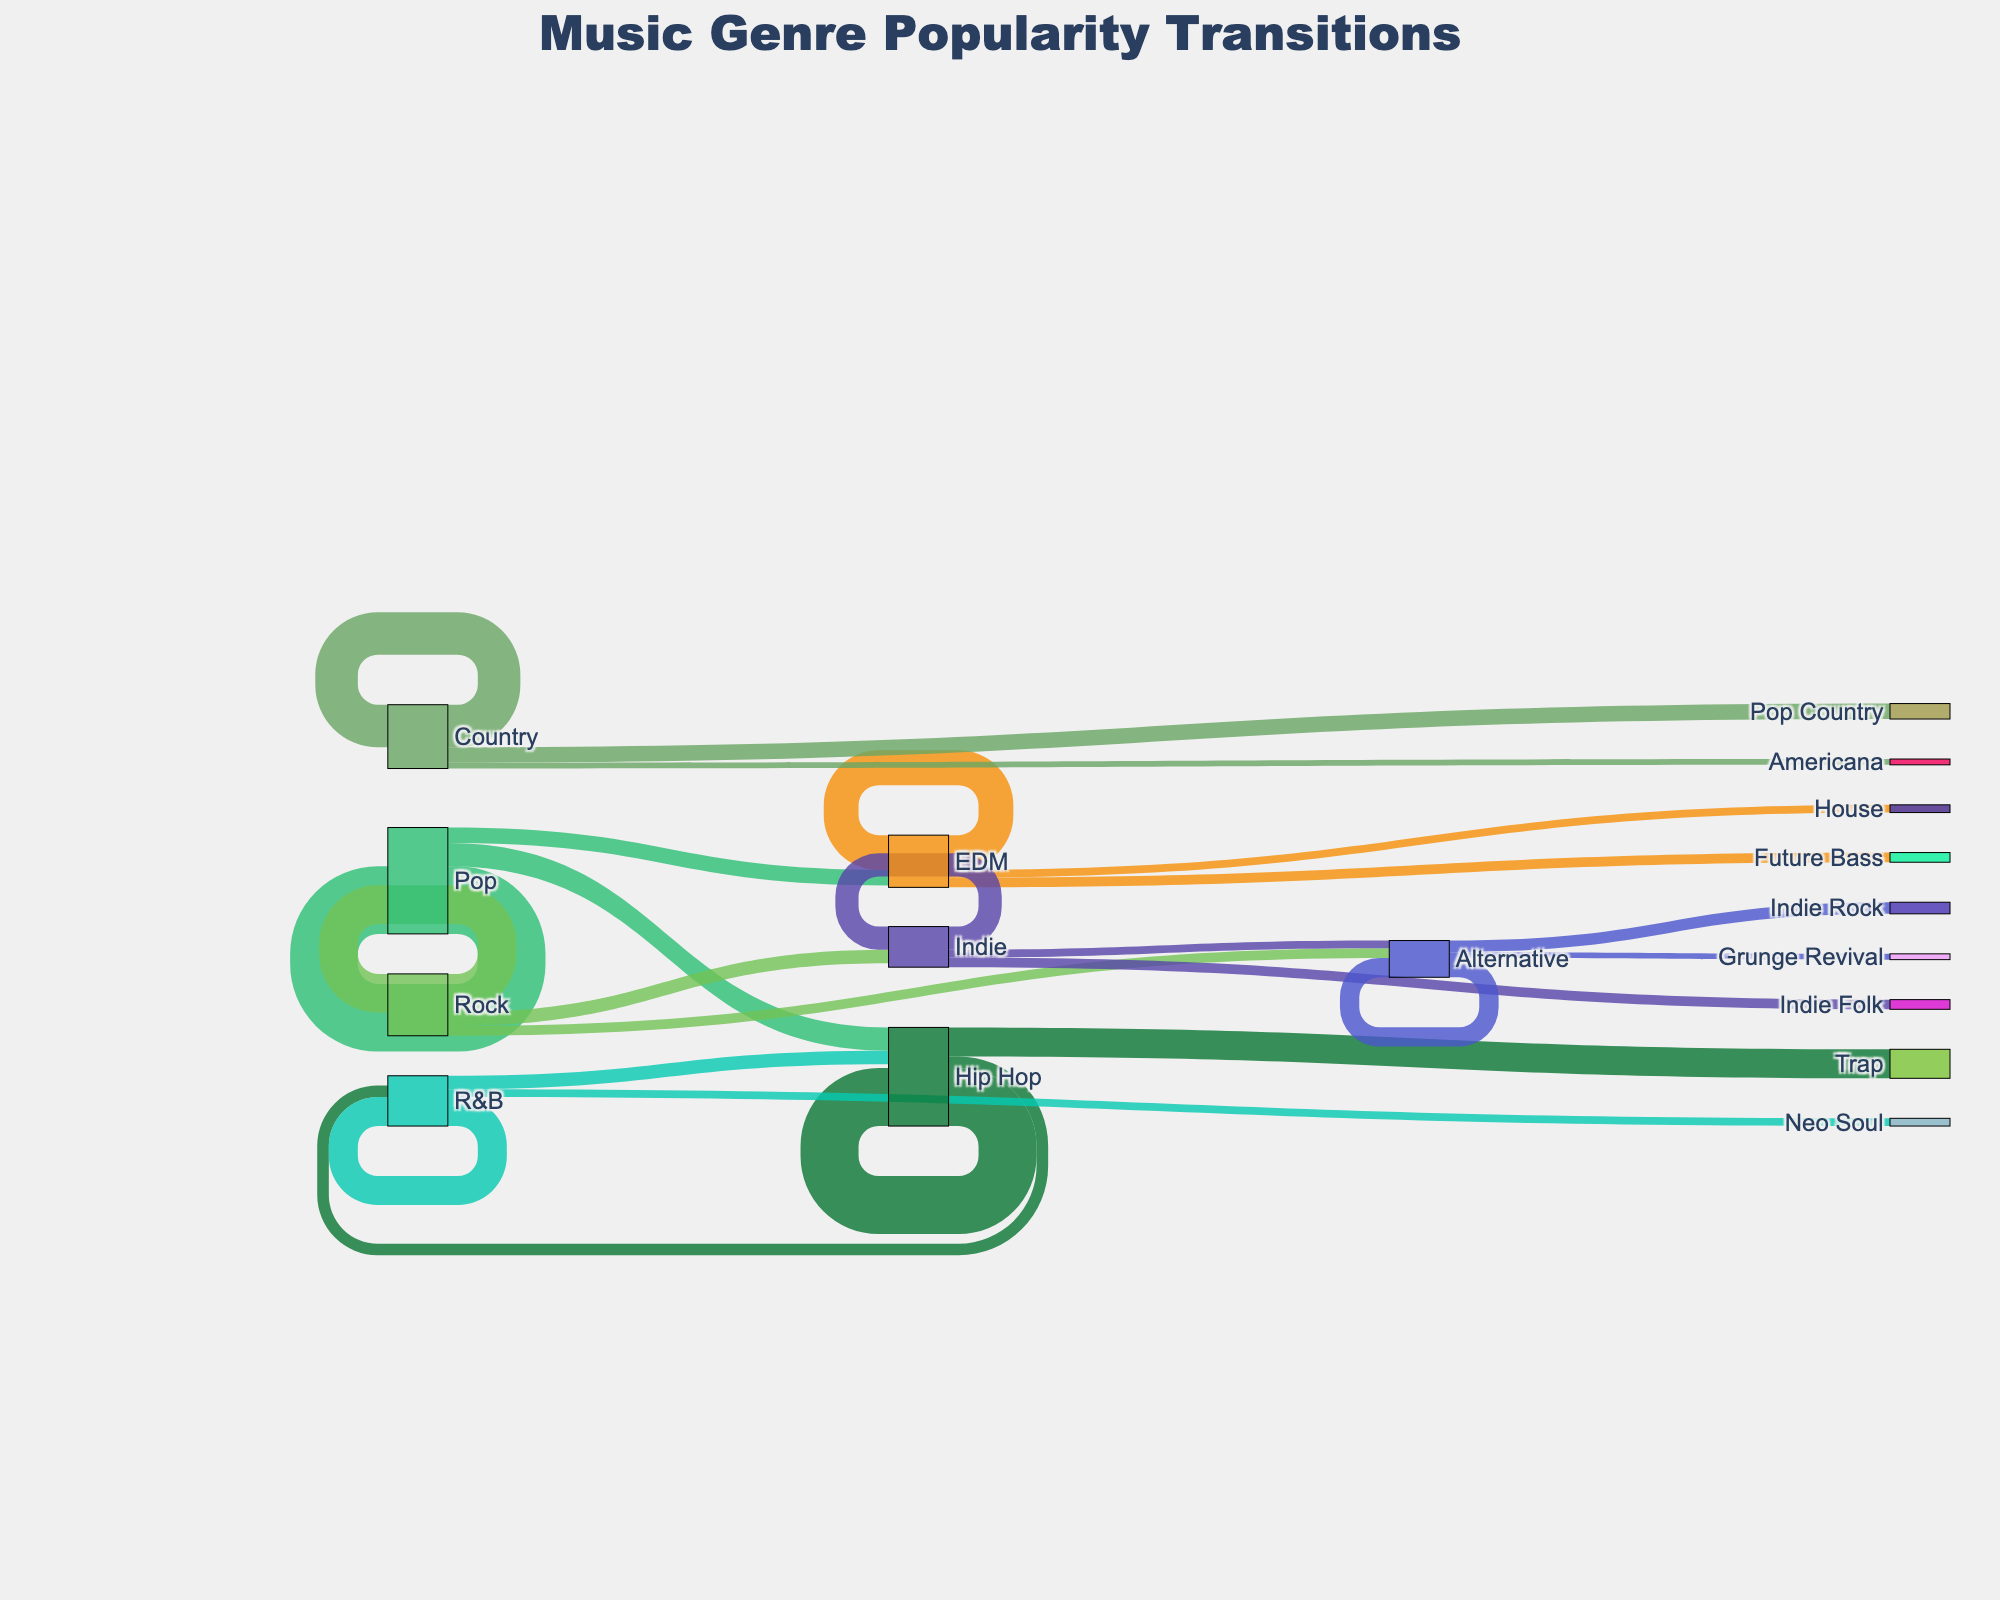What music genre shows the highest retention, where fans stick with the same genre over the decade? By looking at the flows that loop back to the same genre, we see that Pop retains 35, Rock retains 20, Hip Hop retains 30, EDM retains 18, Country retains 22, R&B retains 15, Indie retains 12, and Alternative retains 10. The highest retention is in Pop.
Answer: Pop What is the total number of transitions away from the Pop genre? Sum transitions away from Pop: Hip Hop (12), EDM (8). So, 12 + 8 = 20
Answer: 20 Which genre had the highest transition to Hip Hop? Look at the flows targeted to Hip Hop: Pop (12) and R&B (7). The highest contribution is from Pop.
Answer: Pop How does the popularity transition from Country compare to Pop regarding diversity in target genres? Country has three target genres (Country, Pop Country, Americana). Pop has three target genres (Pop, Hip Hop, EDM). Both have equal diversity in terms of the number of genres to which their listeners transition.
Answer: Equal What total value flows into EDM from other genres and itself? Sum values targeting EDM: Pop (8), EDM (18). So, 8 + 18 = 26
Answer: 26 Which genre has the most distinct transition targets? Count distinct transition targets from each genre: Pop (3), Rock (3), Hip Hop (3), EDM (3), Country (3), R&B (3), Indie (3), Alternative (3). All genres have the same number of distinct transition targets.
Answer: Equal Which genre had the smallest retention rate? Compare retention flows: Alternative (10), Indie (12), R&B (15), EDM (18), Hip Hop (30), Rock (20), Pop (35), Country (22). The smallest value is in Alternative.
Answer: Alternative What’s the most notable transition into a distinct genre for Hip Hop? Look at transitions from Hip Hop into other genres: Trap (15), R&B (6). The largest value is to Trap.
Answer: Trap What is the sum of all transitions out of the EDM genre (including staying within it)? Sum transitions from EDM: EDM (18), Future Bass (5), House (4). So, 18 + 5 + 4 = 27
Answer: 27 How does the transition from R&B to Hip Hop compare in value to the transition from Pop to Hip Hop? Transition from R&B to Hip Hop is 7, from Pop to Hip Hop is 12. Pop to Hip Hop is greater.
Answer: Pop to Hip Hop is greater 